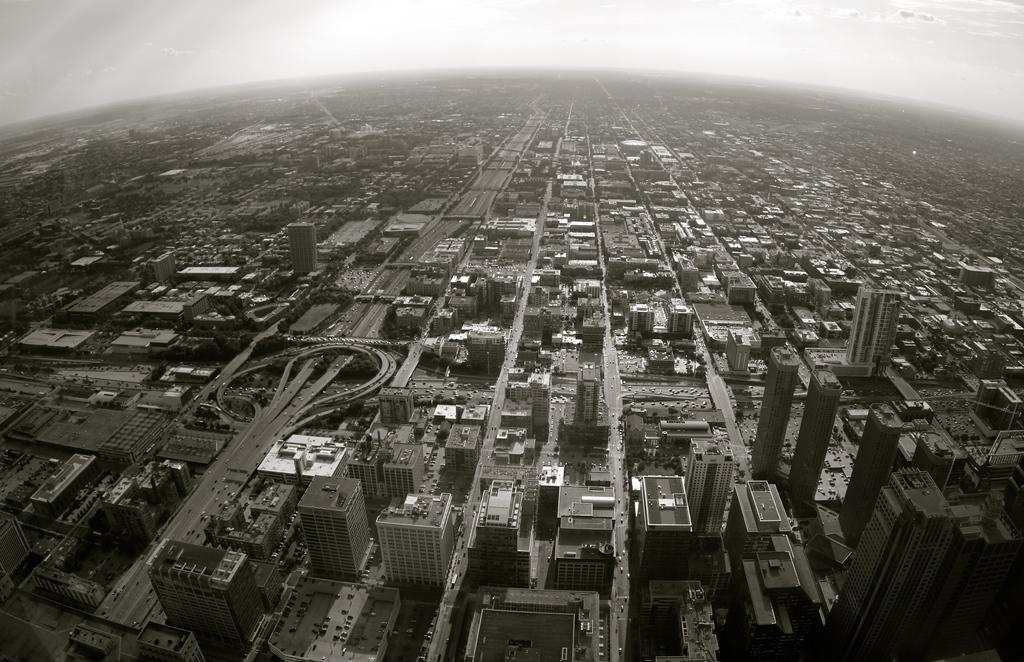In one or two sentences, can you explain what this image depicts? In this image, we can see top view of a city contains buildings and roads. There is a sky at the top of the image. 